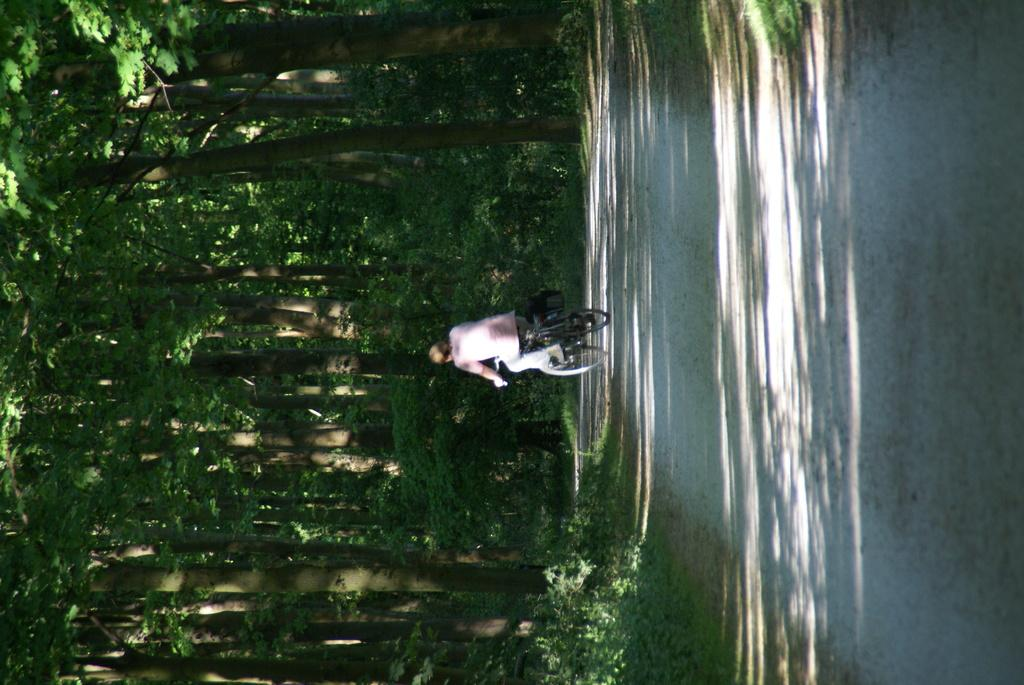What is the main subject of the image? There is a person in the image. What is the person doing in the image? The person is riding a bicycle. What can be seen in the background of the image? There are trees in the background of the image. What type of impulse can be seen affecting the person's ride in the image? There is no mention of an impulse affecting the person's ride in the image. The person is simply riding a bicycle. 